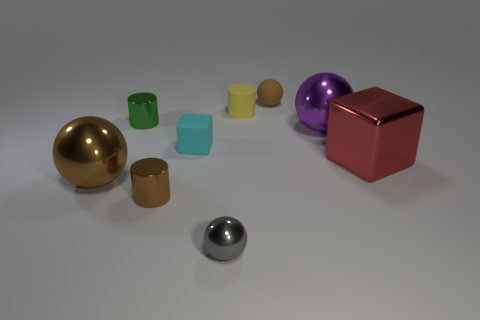What shape is the cyan thing?
Make the answer very short. Cube. Is the number of green things that are in front of the brown metallic cylinder the same as the number of large purple matte cylinders?
Your response must be concise. Yes. What is the size of the other ball that is the same color as the matte ball?
Offer a terse response. Large. Is there a tiny sphere made of the same material as the green cylinder?
Make the answer very short. Yes. Is the shape of the tiny brown thing in front of the cyan matte cube the same as the large purple object that is right of the brown shiny ball?
Your response must be concise. No. Is there a tiny blue cylinder?
Offer a very short reply. No. There is a metal ball that is the same size as the matte sphere; what color is it?
Your answer should be compact. Gray. What number of small gray objects are the same shape as the yellow matte thing?
Your answer should be compact. 0. Is the small brown thing in front of the small brown matte ball made of the same material as the gray ball?
Provide a short and direct response. Yes. What number of cylinders are either brown things or purple metallic objects?
Provide a succinct answer. 1. 